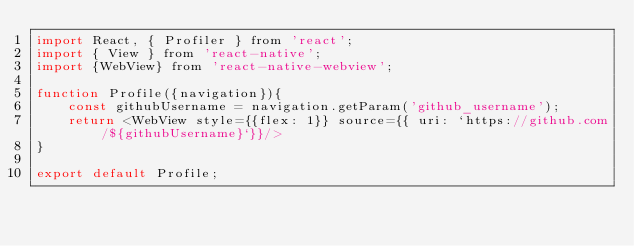Convert code to text. <code><loc_0><loc_0><loc_500><loc_500><_JavaScript_>import React, { Profiler } from 'react';
import { View } from 'react-native';
import {WebView} from 'react-native-webview';

function Profile({navigation}){
    const githubUsername = navigation.getParam('github_username');
    return <WebView style={{flex: 1}} source={{ uri: `https://github.com/${githubUsername}`}}/>
}

export default Profile;</code> 